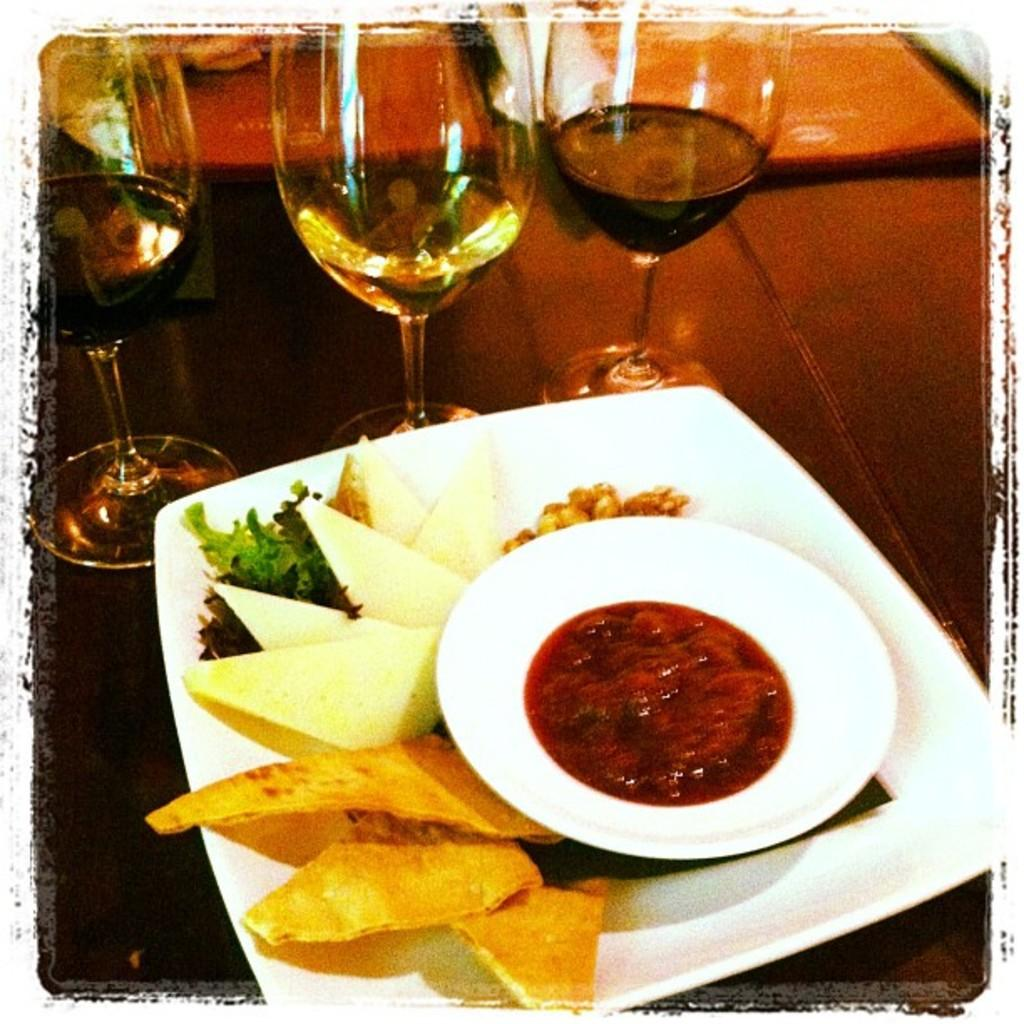What can be seen on the plates in the image? There are two plates containing food in the image. What else is present on the table in the image? There are glasses placed on the table in the image. What can be seen in the background of the image? There are two books visible in the background of the image. What type of print is visible on the books in the image? There is no print visible on the books in the image, as the provided facts do not mention any specific details about the books. 